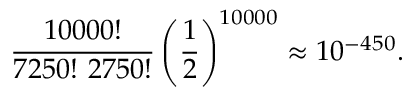Convert formula to latex. <formula><loc_0><loc_0><loc_500><loc_500>\frac { 1 0 0 0 0 ! } { 7 2 5 0 ! \ 2 7 5 0 ! } \left ( \frac { 1 } { 2 } \right ) ^ { 1 0 0 0 0 } \approx 1 0 ^ { - 4 5 0 } .</formula> 